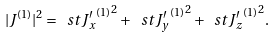<formula> <loc_0><loc_0><loc_500><loc_500>| { J } ^ { ( 1 ) } | ^ { 2 } = \ s t { { J _ { x } ^ { \prime } } ^ { ( 1 ) } } ^ { 2 } + \ s t { { J _ { y } ^ { \prime } } ^ { ( 1 ) } } ^ { 2 } + \ s t { { J _ { z } ^ { \prime } } ^ { ( 1 ) } } ^ { 2 } .</formula> 